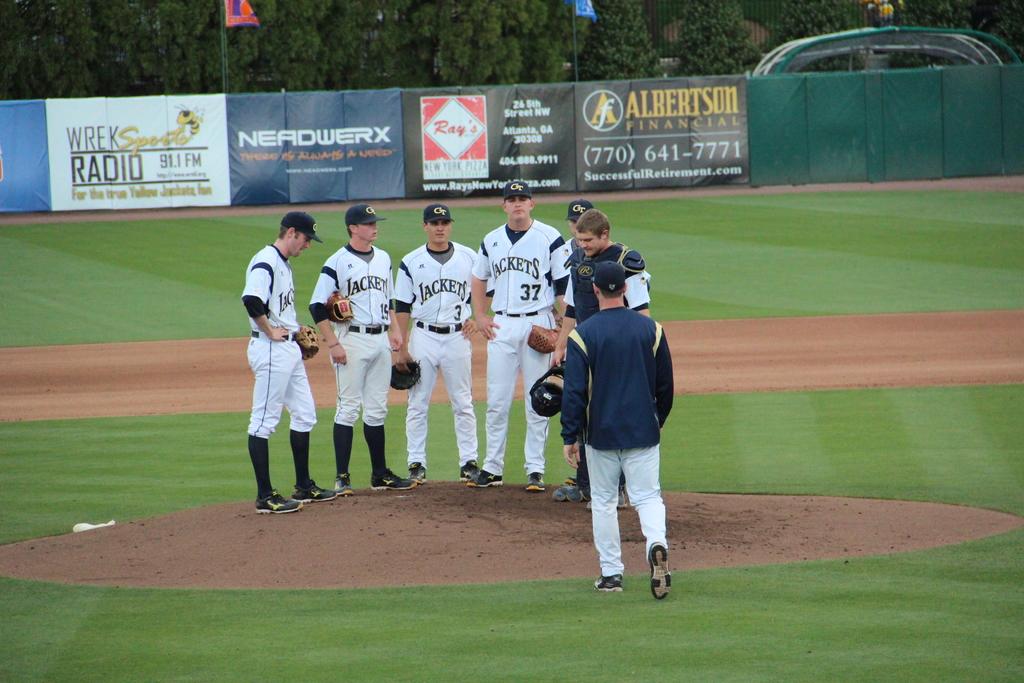What team do the men play for?
Offer a terse response. Jackets. What radio group is advertised on the ad on the fence?
Your answer should be very brief. Wrek. 